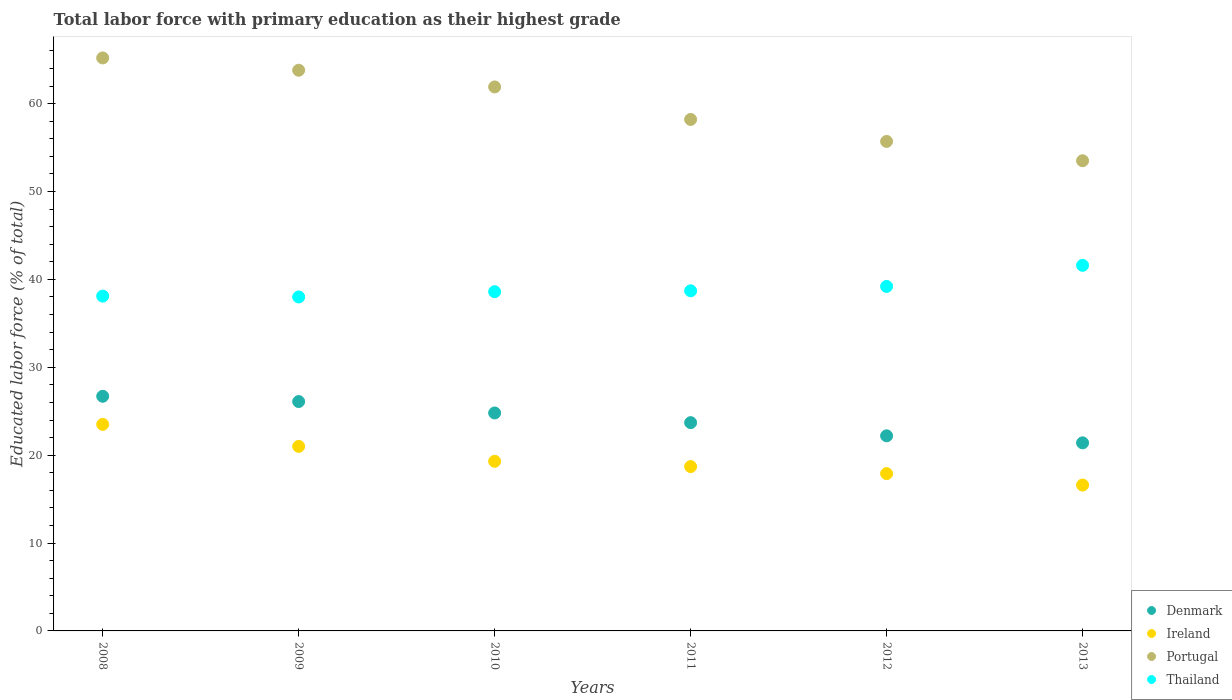What is the percentage of total labor force with primary education in Denmark in 2013?
Ensure brevity in your answer.  21.4. Across all years, what is the maximum percentage of total labor force with primary education in Thailand?
Give a very brief answer. 41.6. Across all years, what is the minimum percentage of total labor force with primary education in Ireland?
Give a very brief answer. 16.6. In which year was the percentage of total labor force with primary education in Denmark maximum?
Make the answer very short. 2008. What is the total percentage of total labor force with primary education in Ireland in the graph?
Make the answer very short. 117. What is the difference between the percentage of total labor force with primary education in Ireland in 2012 and that in 2013?
Make the answer very short. 1.3. What is the difference between the percentage of total labor force with primary education in Portugal in 2011 and the percentage of total labor force with primary education in Denmark in 2008?
Provide a short and direct response. 31.5. What is the average percentage of total labor force with primary education in Denmark per year?
Keep it short and to the point. 24.15. In the year 2013, what is the difference between the percentage of total labor force with primary education in Denmark and percentage of total labor force with primary education in Thailand?
Ensure brevity in your answer.  -20.2. In how many years, is the percentage of total labor force with primary education in Portugal greater than 42 %?
Your answer should be very brief. 6. What is the ratio of the percentage of total labor force with primary education in Portugal in 2010 to that in 2011?
Provide a succinct answer. 1.06. Is the percentage of total labor force with primary education in Portugal in 2010 less than that in 2013?
Your answer should be compact. No. Is the difference between the percentage of total labor force with primary education in Denmark in 2008 and 2011 greater than the difference between the percentage of total labor force with primary education in Thailand in 2008 and 2011?
Give a very brief answer. Yes. What is the difference between the highest and the second highest percentage of total labor force with primary education in Ireland?
Give a very brief answer. 2.5. What is the difference between the highest and the lowest percentage of total labor force with primary education in Thailand?
Make the answer very short. 3.6. In how many years, is the percentage of total labor force with primary education in Portugal greater than the average percentage of total labor force with primary education in Portugal taken over all years?
Your answer should be compact. 3. Is the percentage of total labor force with primary education in Thailand strictly greater than the percentage of total labor force with primary education in Ireland over the years?
Give a very brief answer. Yes. Is the percentage of total labor force with primary education in Ireland strictly less than the percentage of total labor force with primary education in Portugal over the years?
Offer a terse response. Yes. How many dotlines are there?
Ensure brevity in your answer.  4. Does the graph contain any zero values?
Keep it short and to the point. No. How many legend labels are there?
Your answer should be compact. 4. How are the legend labels stacked?
Your response must be concise. Vertical. What is the title of the graph?
Offer a very short reply. Total labor force with primary education as their highest grade. Does "Jamaica" appear as one of the legend labels in the graph?
Your response must be concise. No. What is the label or title of the Y-axis?
Make the answer very short. Educated labor force (% of total). What is the Educated labor force (% of total) of Denmark in 2008?
Your answer should be very brief. 26.7. What is the Educated labor force (% of total) in Portugal in 2008?
Ensure brevity in your answer.  65.2. What is the Educated labor force (% of total) in Thailand in 2008?
Provide a short and direct response. 38.1. What is the Educated labor force (% of total) in Denmark in 2009?
Provide a short and direct response. 26.1. What is the Educated labor force (% of total) of Portugal in 2009?
Ensure brevity in your answer.  63.8. What is the Educated labor force (% of total) in Denmark in 2010?
Your answer should be very brief. 24.8. What is the Educated labor force (% of total) in Ireland in 2010?
Your response must be concise. 19.3. What is the Educated labor force (% of total) in Portugal in 2010?
Your response must be concise. 61.9. What is the Educated labor force (% of total) of Thailand in 2010?
Keep it short and to the point. 38.6. What is the Educated labor force (% of total) in Denmark in 2011?
Provide a succinct answer. 23.7. What is the Educated labor force (% of total) of Ireland in 2011?
Your answer should be very brief. 18.7. What is the Educated labor force (% of total) in Portugal in 2011?
Make the answer very short. 58.2. What is the Educated labor force (% of total) of Thailand in 2011?
Your response must be concise. 38.7. What is the Educated labor force (% of total) in Denmark in 2012?
Provide a succinct answer. 22.2. What is the Educated labor force (% of total) in Ireland in 2012?
Offer a terse response. 17.9. What is the Educated labor force (% of total) in Portugal in 2012?
Give a very brief answer. 55.7. What is the Educated labor force (% of total) in Thailand in 2012?
Make the answer very short. 39.2. What is the Educated labor force (% of total) of Denmark in 2013?
Ensure brevity in your answer.  21.4. What is the Educated labor force (% of total) of Ireland in 2013?
Give a very brief answer. 16.6. What is the Educated labor force (% of total) in Portugal in 2013?
Your response must be concise. 53.5. What is the Educated labor force (% of total) of Thailand in 2013?
Ensure brevity in your answer.  41.6. Across all years, what is the maximum Educated labor force (% of total) of Denmark?
Your response must be concise. 26.7. Across all years, what is the maximum Educated labor force (% of total) of Ireland?
Provide a succinct answer. 23.5. Across all years, what is the maximum Educated labor force (% of total) in Portugal?
Provide a short and direct response. 65.2. Across all years, what is the maximum Educated labor force (% of total) of Thailand?
Offer a very short reply. 41.6. Across all years, what is the minimum Educated labor force (% of total) in Denmark?
Keep it short and to the point. 21.4. Across all years, what is the minimum Educated labor force (% of total) in Ireland?
Your answer should be very brief. 16.6. Across all years, what is the minimum Educated labor force (% of total) of Portugal?
Your answer should be very brief. 53.5. What is the total Educated labor force (% of total) of Denmark in the graph?
Keep it short and to the point. 144.9. What is the total Educated labor force (% of total) in Ireland in the graph?
Your answer should be compact. 117. What is the total Educated labor force (% of total) in Portugal in the graph?
Keep it short and to the point. 358.3. What is the total Educated labor force (% of total) in Thailand in the graph?
Make the answer very short. 234.2. What is the difference between the Educated labor force (% of total) in Ireland in 2008 and that in 2009?
Your answer should be compact. 2.5. What is the difference between the Educated labor force (% of total) of Thailand in 2008 and that in 2009?
Provide a short and direct response. 0.1. What is the difference between the Educated labor force (% of total) in Denmark in 2008 and that in 2010?
Provide a succinct answer. 1.9. What is the difference between the Educated labor force (% of total) in Ireland in 2008 and that in 2010?
Provide a succinct answer. 4.2. What is the difference between the Educated labor force (% of total) of Portugal in 2008 and that in 2010?
Make the answer very short. 3.3. What is the difference between the Educated labor force (% of total) of Denmark in 2008 and that in 2011?
Your answer should be very brief. 3. What is the difference between the Educated labor force (% of total) of Thailand in 2008 and that in 2011?
Give a very brief answer. -0.6. What is the difference between the Educated labor force (% of total) in Denmark in 2008 and that in 2012?
Ensure brevity in your answer.  4.5. What is the difference between the Educated labor force (% of total) in Ireland in 2008 and that in 2012?
Your response must be concise. 5.6. What is the difference between the Educated labor force (% of total) in Ireland in 2008 and that in 2013?
Your answer should be very brief. 6.9. What is the difference between the Educated labor force (% of total) of Thailand in 2008 and that in 2013?
Give a very brief answer. -3.5. What is the difference between the Educated labor force (% of total) in Denmark in 2009 and that in 2010?
Offer a very short reply. 1.3. What is the difference between the Educated labor force (% of total) of Ireland in 2009 and that in 2010?
Keep it short and to the point. 1.7. What is the difference between the Educated labor force (% of total) in Portugal in 2009 and that in 2010?
Your answer should be compact. 1.9. What is the difference between the Educated labor force (% of total) in Portugal in 2009 and that in 2011?
Make the answer very short. 5.6. What is the difference between the Educated labor force (% of total) in Thailand in 2009 and that in 2011?
Your response must be concise. -0.7. What is the difference between the Educated labor force (% of total) in Thailand in 2009 and that in 2012?
Ensure brevity in your answer.  -1.2. What is the difference between the Educated labor force (% of total) of Denmark in 2009 and that in 2013?
Offer a terse response. 4.7. What is the difference between the Educated labor force (% of total) of Ireland in 2009 and that in 2013?
Your response must be concise. 4.4. What is the difference between the Educated labor force (% of total) of Portugal in 2009 and that in 2013?
Your answer should be compact. 10.3. What is the difference between the Educated labor force (% of total) of Portugal in 2010 and that in 2011?
Provide a short and direct response. 3.7. What is the difference between the Educated labor force (% of total) in Thailand in 2010 and that in 2011?
Give a very brief answer. -0.1. What is the difference between the Educated labor force (% of total) of Portugal in 2010 and that in 2012?
Provide a short and direct response. 6.2. What is the difference between the Educated labor force (% of total) of Thailand in 2010 and that in 2012?
Keep it short and to the point. -0.6. What is the difference between the Educated labor force (% of total) of Portugal in 2010 and that in 2013?
Provide a succinct answer. 8.4. What is the difference between the Educated labor force (% of total) of Thailand in 2010 and that in 2013?
Your answer should be compact. -3. What is the difference between the Educated labor force (% of total) of Ireland in 2011 and that in 2012?
Offer a very short reply. 0.8. What is the difference between the Educated labor force (% of total) of Portugal in 2011 and that in 2012?
Your response must be concise. 2.5. What is the difference between the Educated labor force (% of total) in Denmark in 2011 and that in 2013?
Make the answer very short. 2.3. What is the difference between the Educated labor force (% of total) of Portugal in 2011 and that in 2013?
Offer a very short reply. 4.7. What is the difference between the Educated labor force (% of total) in Thailand in 2011 and that in 2013?
Provide a succinct answer. -2.9. What is the difference between the Educated labor force (% of total) in Thailand in 2012 and that in 2013?
Your answer should be very brief. -2.4. What is the difference between the Educated labor force (% of total) of Denmark in 2008 and the Educated labor force (% of total) of Ireland in 2009?
Make the answer very short. 5.7. What is the difference between the Educated labor force (% of total) in Denmark in 2008 and the Educated labor force (% of total) in Portugal in 2009?
Your response must be concise. -37.1. What is the difference between the Educated labor force (% of total) in Ireland in 2008 and the Educated labor force (% of total) in Portugal in 2009?
Offer a terse response. -40.3. What is the difference between the Educated labor force (% of total) of Ireland in 2008 and the Educated labor force (% of total) of Thailand in 2009?
Provide a short and direct response. -14.5. What is the difference between the Educated labor force (% of total) of Portugal in 2008 and the Educated labor force (% of total) of Thailand in 2009?
Give a very brief answer. 27.2. What is the difference between the Educated labor force (% of total) in Denmark in 2008 and the Educated labor force (% of total) in Ireland in 2010?
Ensure brevity in your answer.  7.4. What is the difference between the Educated labor force (% of total) in Denmark in 2008 and the Educated labor force (% of total) in Portugal in 2010?
Provide a succinct answer. -35.2. What is the difference between the Educated labor force (% of total) of Denmark in 2008 and the Educated labor force (% of total) of Thailand in 2010?
Provide a succinct answer. -11.9. What is the difference between the Educated labor force (% of total) in Ireland in 2008 and the Educated labor force (% of total) in Portugal in 2010?
Make the answer very short. -38.4. What is the difference between the Educated labor force (% of total) in Ireland in 2008 and the Educated labor force (% of total) in Thailand in 2010?
Your answer should be compact. -15.1. What is the difference between the Educated labor force (% of total) of Portugal in 2008 and the Educated labor force (% of total) of Thailand in 2010?
Offer a terse response. 26.6. What is the difference between the Educated labor force (% of total) of Denmark in 2008 and the Educated labor force (% of total) of Portugal in 2011?
Provide a short and direct response. -31.5. What is the difference between the Educated labor force (% of total) of Denmark in 2008 and the Educated labor force (% of total) of Thailand in 2011?
Your response must be concise. -12. What is the difference between the Educated labor force (% of total) in Ireland in 2008 and the Educated labor force (% of total) in Portugal in 2011?
Keep it short and to the point. -34.7. What is the difference between the Educated labor force (% of total) of Ireland in 2008 and the Educated labor force (% of total) of Thailand in 2011?
Keep it short and to the point. -15.2. What is the difference between the Educated labor force (% of total) in Portugal in 2008 and the Educated labor force (% of total) in Thailand in 2011?
Your answer should be very brief. 26.5. What is the difference between the Educated labor force (% of total) in Denmark in 2008 and the Educated labor force (% of total) in Ireland in 2012?
Your response must be concise. 8.8. What is the difference between the Educated labor force (% of total) in Ireland in 2008 and the Educated labor force (% of total) in Portugal in 2012?
Make the answer very short. -32.2. What is the difference between the Educated labor force (% of total) of Ireland in 2008 and the Educated labor force (% of total) of Thailand in 2012?
Make the answer very short. -15.7. What is the difference between the Educated labor force (% of total) of Portugal in 2008 and the Educated labor force (% of total) of Thailand in 2012?
Ensure brevity in your answer.  26. What is the difference between the Educated labor force (% of total) in Denmark in 2008 and the Educated labor force (% of total) in Portugal in 2013?
Provide a succinct answer. -26.8. What is the difference between the Educated labor force (% of total) in Denmark in 2008 and the Educated labor force (% of total) in Thailand in 2013?
Offer a terse response. -14.9. What is the difference between the Educated labor force (% of total) of Ireland in 2008 and the Educated labor force (% of total) of Portugal in 2013?
Your answer should be compact. -30. What is the difference between the Educated labor force (% of total) of Ireland in 2008 and the Educated labor force (% of total) of Thailand in 2013?
Offer a terse response. -18.1. What is the difference between the Educated labor force (% of total) of Portugal in 2008 and the Educated labor force (% of total) of Thailand in 2013?
Your answer should be very brief. 23.6. What is the difference between the Educated labor force (% of total) in Denmark in 2009 and the Educated labor force (% of total) in Ireland in 2010?
Keep it short and to the point. 6.8. What is the difference between the Educated labor force (% of total) of Denmark in 2009 and the Educated labor force (% of total) of Portugal in 2010?
Provide a short and direct response. -35.8. What is the difference between the Educated labor force (% of total) of Denmark in 2009 and the Educated labor force (% of total) of Thailand in 2010?
Give a very brief answer. -12.5. What is the difference between the Educated labor force (% of total) of Ireland in 2009 and the Educated labor force (% of total) of Portugal in 2010?
Your answer should be very brief. -40.9. What is the difference between the Educated labor force (% of total) of Ireland in 2009 and the Educated labor force (% of total) of Thailand in 2010?
Offer a very short reply. -17.6. What is the difference between the Educated labor force (% of total) of Portugal in 2009 and the Educated labor force (% of total) of Thailand in 2010?
Provide a succinct answer. 25.2. What is the difference between the Educated labor force (% of total) in Denmark in 2009 and the Educated labor force (% of total) in Ireland in 2011?
Keep it short and to the point. 7.4. What is the difference between the Educated labor force (% of total) of Denmark in 2009 and the Educated labor force (% of total) of Portugal in 2011?
Offer a terse response. -32.1. What is the difference between the Educated labor force (% of total) of Denmark in 2009 and the Educated labor force (% of total) of Thailand in 2011?
Your response must be concise. -12.6. What is the difference between the Educated labor force (% of total) in Ireland in 2009 and the Educated labor force (% of total) in Portugal in 2011?
Offer a very short reply. -37.2. What is the difference between the Educated labor force (% of total) of Ireland in 2009 and the Educated labor force (% of total) of Thailand in 2011?
Your answer should be compact. -17.7. What is the difference between the Educated labor force (% of total) of Portugal in 2009 and the Educated labor force (% of total) of Thailand in 2011?
Your answer should be compact. 25.1. What is the difference between the Educated labor force (% of total) of Denmark in 2009 and the Educated labor force (% of total) of Ireland in 2012?
Your response must be concise. 8.2. What is the difference between the Educated labor force (% of total) of Denmark in 2009 and the Educated labor force (% of total) of Portugal in 2012?
Your answer should be very brief. -29.6. What is the difference between the Educated labor force (% of total) of Ireland in 2009 and the Educated labor force (% of total) of Portugal in 2012?
Your response must be concise. -34.7. What is the difference between the Educated labor force (% of total) in Ireland in 2009 and the Educated labor force (% of total) in Thailand in 2012?
Provide a succinct answer. -18.2. What is the difference between the Educated labor force (% of total) of Portugal in 2009 and the Educated labor force (% of total) of Thailand in 2012?
Offer a very short reply. 24.6. What is the difference between the Educated labor force (% of total) of Denmark in 2009 and the Educated labor force (% of total) of Ireland in 2013?
Offer a very short reply. 9.5. What is the difference between the Educated labor force (% of total) of Denmark in 2009 and the Educated labor force (% of total) of Portugal in 2013?
Your answer should be very brief. -27.4. What is the difference between the Educated labor force (% of total) in Denmark in 2009 and the Educated labor force (% of total) in Thailand in 2013?
Your response must be concise. -15.5. What is the difference between the Educated labor force (% of total) of Ireland in 2009 and the Educated labor force (% of total) of Portugal in 2013?
Give a very brief answer. -32.5. What is the difference between the Educated labor force (% of total) of Ireland in 2009 and the Educated labor force (% of total) of Thailand in 2013?
Make the answer very short. -20.6. What is the difference between the Educated labor force (% of total) in Portugal in 2009 and the Educated labor force (% of total) in Thailand in 2013?
Offer a terse response. 22.2. What is the difference between the Educated labor force (% of total) in Denmark in 2010 and the Educated labor force (% of total) in Ireland in 2011?
Provide a short and direct response. 6.1. What is the difference between the Educated labor force (% of total) of Denmark in 2010 and the Educated labor force (% of total) of Portugal in 2011?
Keep it short and to the point. -33.4. What is the difference between the Educated labor force (% of total) in Denmark in 2010 and the Educated labor force (% of total) in Thailand in 2011?
Provide a short and direct response. -13.9. What is the difference between the Educated labor force (% of total) in Ireland in 2010 and the Educated labor force (% of total) in Portugal in 2011?
Offer a very short reply. -38.9. What is the difference between the Educated labor force (% of total) of Ireland in 2010 and the Educated labor force (% of total) of Thailand in 2011?
Provide a short and direct response. -19.4. What is the difference between the Educated labor force (% of total) of Portugal in 2010 and the Educated labor force (% of total) of Thailand in 2011?
Provide a short and direct response. 23.2. What is the difference between the Educated labor force (% of total) of Denmark in 2010 and the Educated labor force (% of total) of Ireland in 2012?
Provide a succinct answer. 6.9. What is the difference between the Educated labor force (% of total) of Denmark in 2010 and the Educated labor force (% of total) of Portugal in 2012?
Keep it short and to the point. -30.9. What is the difference between the Educated labor force (% of total) in Denmark in 2010 and the Educated labor force (% of total) in Thailand in 2012?
Your response must be concise. -14.4. What is the difference between the Educated labor force (% of total) in Ireland in 2010 and the Educated labor force (% of total) in Portugal in 2012?
Give a very brief answer. -36.4. What is the difference between the Educated labor force (% of total) of Ireland in 2010 and the Educated labor force (% of total) of Thailand in 2012?
Your answer should be very brief. -19.9. What is the difference between the Educated labor force (% of total) of Portugal in 2010 and the Educated labor force (% of total) of Thailand in 2012?
Give a very brief answer. 22.7. What is the difference between the Educated labor force (% of total) in Denmark in 2010 and the Educated labor force (% of total) in Ireland in 2013?
Keep it short and to the point. 8.2. What is the difference between the Educated labor force (% of total) in Denmark in 2010 and the Educated labor force (% of total) in Portugal in 2013?
Make the answer very short. -28.7. What is the difference between the Educated labor force (% of total) of Denmark in 2010 and the Educated labor force (% of total) of Thailand in 2013?
Offer a terse response. -16.8. What is the difference between the Educated labor force (% of total) in Ireland in 2010 and the Educated labor force (% of total) in Portugal in 2013?
Your response must be concise. -34.2. What is the difference between the Educated labor force (% of total) in Ireland in 2010 and the Educated labor force (% of total) in Thailand in 2013?
Offer a very short reply. -22.3. What is the difference between the Educated labor force (% of total) of Portugal in 2010 and the Educated labor force (% of total) of Thailand in 2013?
Give a very brief answer. 20.3. What is the difference between the Educated labor force (% of total) in Denmark in 2011 and the Educated labor force (% of total) in Portugal in 2012?
Offer a very short reply. -32. What is the difference between the Educated labor force (% of total) of Denmark in 2011 and the Educated labor force (% of total) of Thailand in 2012?
Your answer should be very brief. -15.5. What is the difference between the Educated labor force (% of total) of Ireland in 2011 and the Educated labor force (% of total) of Portugal in 2012?
Your answer should be compact. -37. What is the difference between the Educated labor force (% of total) of Ireland in 2011 and the Educated labor force (% of total) of Thailand in 2012?
Your answer should be compact. -20.5. What is the difference between the Educated labor force (% of total) of Portugal in 2011 and the Educated labor force (% of total) of Thailand in 2012?
Keep it short and to the point. 19. What is the difference between the Educated labor force (% of total) of Denmark in 2011 and the Educated labor force (% of total) of Ireland in 2013?
Provide a succinct answer. 7.1. What is the difference between the Educated labor force (% of total) of Denmark in 2011 and the Educated labor force (% of total) of Portugal in 2013?
Offer a terse response. -29.8. What is the difference between the Educated labor force (% of total) in Denmark in 2011 and the Educated labor force (% of total) in Thailand in 2013?
Your answer should be compact. -17.9. What is the difference between the Educated labor force (% of total) in Ireland in 2011 and the Educated labor force (% of total) in Portugal in 2013?
Make the answer very short. -34.8. What is the difference between the Educated labor force (% of total) of Ireland in 2011 and the Educated labor force (% of total) of Thailand in 2013?
Provide a succinct answer. -22.9. What is the difference between the Educated labor force (% of total) of Denmark in 2012 and the Educated labor force (% of total) of Portugal in 2013?
Provide a succinct answer. -31.3. What is the difference between the Educated labor force (% of total) of Denmark in 2012 and the Educated labor force (% of total) of Thailand in 2013?
Give a very brief answer. -19.4. What is the difference between the Educated labor force (% of total) of Ireland in 2012 and the Educated labor force (% of total) of Portugal in 2013?
Make the answer very short. -35.6. What is the difference between the Educated labor force (% of total) of Ireland in 2012 and the Educated labor force (% of total) of Thailand in 2013?
Ensure brevity in your answer.  -23.7. What is the difference between the Educated labor force (% of total) in Portugal in 2012 and the Educated labor force (% of total) in Thailand in 2013?
Offer a terse response. 14.1. What is the average Educated labor force (% of total) in Denmark per year?
Your answer should be compact. 24.15. What is the average Educated labor force (% of total) in Ireland per year?
Provide a succinct answer. 19.5. What is the average Educated labor force (% of total) in Portugal per year?
Make the answer very short. 59.72. What is the average Educated labor force (% of total) of Thailand per year?
Keep it short and to the point. 39.03. In the year 2008, what is the difference between the Educated labor force (% of total) in Denmark and Educated labor force (% of total) in Portugal?
Keep it short and to the point. -38.5. In the year 2008, what is the difference between the Educated labor force (% of total) in Denmark and Educated labor force (% of total) in Thailand?
Your answer should be very brief. -11.4. In the year 2008, what is the difference between the Educated labor force (% of total) in Ireland and Educated labor force (% of total) in Portugal?
Give a very brief answer. -41.7. In the year 2008, what is the difference between the Educated labor force (% of total) of Ireland and Educated labor force (% of total) of Thailand?
Offer a terse response. -14.6. In the year 2008, what is the difference between the Educated labor force (% of total) in Portugal and Educated labor force (% of total) in Thailand?
Offer a terse response. 27.1. In the year 2009, what is the difference between the Educated labor force (% of total) of Denmark and Educated labor force (% of total) of Ireland?
Your answer should be very brief. 5.1. In the year 2009, what is the difference between the Educated labor force (% of total) of Denmark and Educated labor force (% of total) of Portugal?
Keep it short and to the point. -37.7. In the year 2009, what is the difference between the Educated labor force (% of total) in Denmark and Educated labor force (% of total) in Thailand?
Offer a very short reply. -11.9. In the year 2009, what is the difference between the Educated labor force (% of total) in Ireland and Educated labor force (% of total) in Portugal?
Make the answer very short. -42.8. In the year 2009, what is the difference between the Educated labor force (% of total) of Portugal and Educated labor force (% of total) of Thailand?
Offer a terse response. 25.8. In the year 2010, what is the difference between the Educated labor force (% of total) in Denmark and Educated labor force (% of total) in Portugal?
Offer a very short reply. -37.1. In the year 2010, what is the difference between the Educated labor force (% of total) of Denmark and Educated labor force (% of total) of Thailand?
Your answer should be compact. -13.8. In the year 2010, what is the difference between the Educated labor force (% of total) of Ireland and Educated labor force (% of total) of Portugal?
Keep it short and to the point. -42.6. In the year 2010, what is the difference between the Educated labor force (% of total) of Ireland and Educated labor force (% of total) of Thailand?
Ensure brevity in your answer.  -19.3. In the year 2010, what is the difference between the Educated labor force (% of total) in Portugal and Educated labor force (% of total) in Thailand?
Keep it short and to the point. 23.3. In the year 2011, what is the difference between the Educated labor force (% of total) of Denmark and Educated labor force (% of total) of Portugal?
Make the answer very short. -34.5. In the year 2011, what is the difference between the Educated labor force (% of total) of Ireland and Educated labor force (% of total) of Portugal?
Your answer should be compact. -39.5. In the year 2011, what is the difference between the Educated labor force (% of total) in Ireland and Educated labor force (% of total) in Thailand?
Keep it short and to the point. -20. In the year 2012, what is the difference between the Educated labor force (% of total) of Denmark and Educated labor force (% of total) of Ireland?
Offer a terse response. 4.3. In the year 2012, what is the difference between the Educated labor force (% of total) of Denmark and Educated labor force (% of total) of Portugal?
Your answer should be very brief. -33.5. In the year 2012, what is the difference between the Educated labor force (% of total) in Denmark and Educated labor force (% of total) in Thailand?
Provide a succinct answer. -17. In the year 2012, what is the difference between the Educated labor force (% of total) of Ireland and Educated labor force (% of total) of Portugal?
Keep it short and to the point. -37.8. In the year 2012, what is the difference between the Educated labor force (% of total) in Ireland and Educated labor force (% of total) in Thailand?
Your answer should be compact. -21.3. In the year 2012, what is the difference between the Educated labor force (% of total) in Portugal and Educated labor force (% of total) in Thailand?
Make the answer very short. 16.5. In the year 2013, what is the difference between the Educated labor force (% of total) of Denmark and Educated labor force (% of total) of Portugal?
Keep it short and to the point. -32.1. In the year 2013, what is the difference between the Educated labor force (% of total) in Denmark and Educated labor force (% of total) in Thailand?
Give a very brief answer. -20.2. In the year 2013, what is the difference between the Educated labor force (% of total) of Ireland and Educated labor force (% of total) of Portugal?
Provide a succinct answer. -36.9. In the year 2013, what is the difference between the Educated labor force (% of total) of Ireland and Educated labor force (% of total) of Thailand?
Your response must be concise. -25. In the year 2013, what is the difference between the Educated labor force (% of total) in Portugal and Educated labor force (% of total) in Thailand?
Make the answer very short. 11.9. What is the ratio of the Educated labor force (% of total) of Ireland in 2008 to that in 2009?
Your answer should be compact. 1.12. What is the ratio of the Educated labor force (% of total) in Portugal in 2008 to that in 2009?
Provide a succinct answer. 1.02. What is the ratio of the Educated labor force (% of total) in Denmark in 2008 to that in 2010?
Your answer should be compact. 1.08. What is the ratio of the Educated labor force (% of total) of Ireland in 2008 to that in 2010?
Provide a succinct answer. 1.22. What is the ratio of the Educated labor force (% of total) in Portugal in 2008 to that in 2010?
Keep it short and to the point. 1.05. What is the ratio of the Educated labor force (% of total) in Denmark in 2008 to that in 2011?
Ensure brevity in your answer.  1.13. What is the ratio of the Educated labor force (% of total) of Ireland in 2008 to that in 2011?
Your answer should be compact. 1.26. What is the ratio of the Educated labor force (% of total) of Portugal in 2008 to that in 2011?
Make the answer very short. 1.12. What is the ratio of the Educated labor force (% of total) of Thailand in 2008 to that in 2011?
Offer a terse response. 0.98. What is the ratio of the Educated labor force (% of total) in Denmark in 2008 to that in 2012?
Offer a very short reply. 1.2. What is the ratio of the Educated labor force (% of total) in Ireland in 2008 to that in 2012?
Your answer should be compact. 1.31. What is the ratio of the Educated labor force (% of total) of Portugal in 2008 to that in 2012?
Offer a very short reply. 1.17. What is the ratio of the Educated labor force (% of total) in Thailand in 2008 to that in 2012?
Keep it short and to the point. 0.97. What is the ratio of the Educated labor force (% of total) in Denmark in 2008 to that in 2013?
Your answer should be compact. 1.25. What is the ratio of the Educated labor force (% of total) in Ireland in 2008 to that in 2013?
Provide a short and direct response. 1.42. What is the ratio of the Educated labor force (% of total) of Portugal in 2008 to that in 2013?
Your answer should be compact. 1.22. What is the ratio of the Educated labor force (% of total) in Thailand in 2008 to that in 2013?
Give a very brief answer. 0.92. What is the ratio of the Educated labor force (% of total) of Denmark in 2009 to that in 2010?
Offer a very short reply. 1.05. What is the ratio of the Educated labor force (% of total) in Ireland in 2009 to that in 2010?
Ensure brevity in your answer.  1.09. What is the ratio of the Educated labor force (% of total) in Portugal in 2009 to that in 2010?
Provide a succinct answer. 1.03. What is the ratio of the Educated labor force (% of total) in Thailand in 2009 to that in 2010?
Your response must be concise. 0.98. What is the ratio of the Educated labor force (% of total) of Denmark in 2009 to that in 2011?
Ensure brevity in your answer.  1.1. What is the ratio of the Educated labor force (% of total) of Ireland in 2009 to that in 2011?
Ensure brevity in your answer.  1.12. What is the ratio of the Educated labor force (% of total) of Portugal in 2009 to that in 2011?
Provide a short and direct response. 1.1. What is the ratio of the Educated labor force (% of total) in Thailand in 2009 to that in 2011?
Your answer should be compact. 0.98. What is the ratio of the Educated labor force (% of total) in Denmark in 2009 to that in 2012?
Keep it short and to the point. 1.18. What is the ratio of the Educated labor force (% of total) in Ireland in 2009 to that in 2012?
Provide a short and direct response. 1.17. What is the ratio of the Educated labor force (% of total) of Portugal in 2009 to that in 2012?
Ensure brevity in your answer.  1.15. What is the ratio of the Educated labor force (% of total) in Thailand in 2009 to that in 2012?
Your answer should be compact. 0.97. What is the ratio of the Educated labor force (% of total) in Denmark in 2009 to that in 2013?
Ensure brevity in your answer.  1.22. What is the ratio of the Educated labor force (% of total) in Ireland in 2009 to that in 2013?
Make the answer very short. 1.27. What is the ratio of the Educated labor force (% of total) of Portugal in 2009 to that in 2013?
Provide a succinct answer. 1.19. What is the ratio of the Educated labor force (% of total) of Thailand in 2009 to that in 2013?
Offer a terse response. 0.91. What is the ratio of the Educated labor force (% of total) in Denmark in 2010 to that in 2011?
Offer a very short reply. 1.05. What is the ratio of the Educated labor force (% of total) in Ireland in 2010 to that in 2011?
Offer a very short reply. 1.03. What is the ratio of the Educated labor force (% of total) of Portugal in 2010 to that in 2011?
Offer a terse response. 1.06. What is the ratio of the Educated labor force (% of total) in Denmark in 2010 to that in 2012?
Provide a succinct answer. 1.12. What is the ratio of the Educated labor force (% of total) in Ireland in 2010 to that in 2012?
Provide a short and direct response. 1.08. What is the ratio of the Educated labor force (% of total) of Portugal in 2010 to that in 2012?
Offer a terse response. 1.11. What is the ratio of the Educated labor force (% of total) of Thailand in 2010 to that in 2012?
Your answer should be very brief. 0.98. What is the ratio of the Educated labor force (% of total) in Denmark in 2010 to that in 2013?
Give a very brief answer. 1.16. What is the ratio of the Educated labor force (% of total) in Ireland in 2010 to that in 2013?
Your response must be concise. 1.16. What is the ratio of the Educated labor force (% of total) of Portugal in 2010 to that in 2013?
Ensure brevity in your answer.  1.16. What is the ratio of the Educated labor force (% of total) of Thailand in 2010 to that in 2013?
Offer a very short reply. 0.93. What is the ratio of the Educated labor force (% of total) in Denmark in 2011 to that in 2012?
Your answer should be compact. 1.07. What is the ratio of the Educated labor force (% of total) of Ireland in 2011 to that in 2012?
Provide a succinct answer. 1.04. What is the ratio of the Educated labor force (% of total) in Portugal in 2011 to that in 2012?
Your answer should be very brief. 1.04. What is the ratio of the Educated labor force (% of total) in Thailand in 2011 to that in 2012?
Provide a succinct answer. 0.99. What is the ratio of the Educated labor force (% of total) of Denmark in 2011 to that in 2013?
Ensure brevity in your answer.  1.11. What is the ratio of the Educated labor force (% of total) of Ireland in 2011 to that in 2013?
Offer a terse response. 1.13. What is the ratio of the Educated labor force (% of total) in Portugal in 2011 to that in 2013?
Your answer should be very brief. 1.09. What is the ratio of the Educated labor force (% of total) in Thailand in 2011 to that in 2013?
Give a very brief answer. 0.93. What is the ratio of the Educated labor force (% of total) in Denmark in 2012 to that in 2013?
Provide a short and direct response. 1.04. What is the ratio of the Educated labor force (% of total) of Ireland in 2012 to that in 2013?
Provide a short and direct response. 1.08. What is the ratio of the Educated labor force (% of total) in Portugal in 2012 to that in 2013?
Provide a short and direct response. 1.04. What is the ratio of the Educated labor force (% of total) in Thailand in 2012 to that in 2013?
Your answer should be very brief. 0.94. What is the difference between the highest and the second highest Educated labor force (% of total) of Denmark?
Offer a very short reply. 0.6. What is the difference between the highest and the second highest Educated labor force (% of total) in Portugal?
Give a very brief answer. 1.4. What is the difference between the highest and the second highest Educated labor force (% of total) in Thailand?
Ensure brevity in your answer.  2.4. What is the difference between the highest and the lowest Educated labor force (% of total) in Denmark?
Make the answer very short. 5.3. What is the difference between the highest and the lowest Educated labor force (% of total) in Ireland?
Make the answer very short. 6.9. What is the difference between the highest and the lowest Educated labor force (% of total) of Portugal?
Offer a very short reply. 11.7. What is the difference between the highest and the lowest Educated labor force (% of total) of Thailand?
Keep it short and to the point. 3.6. 